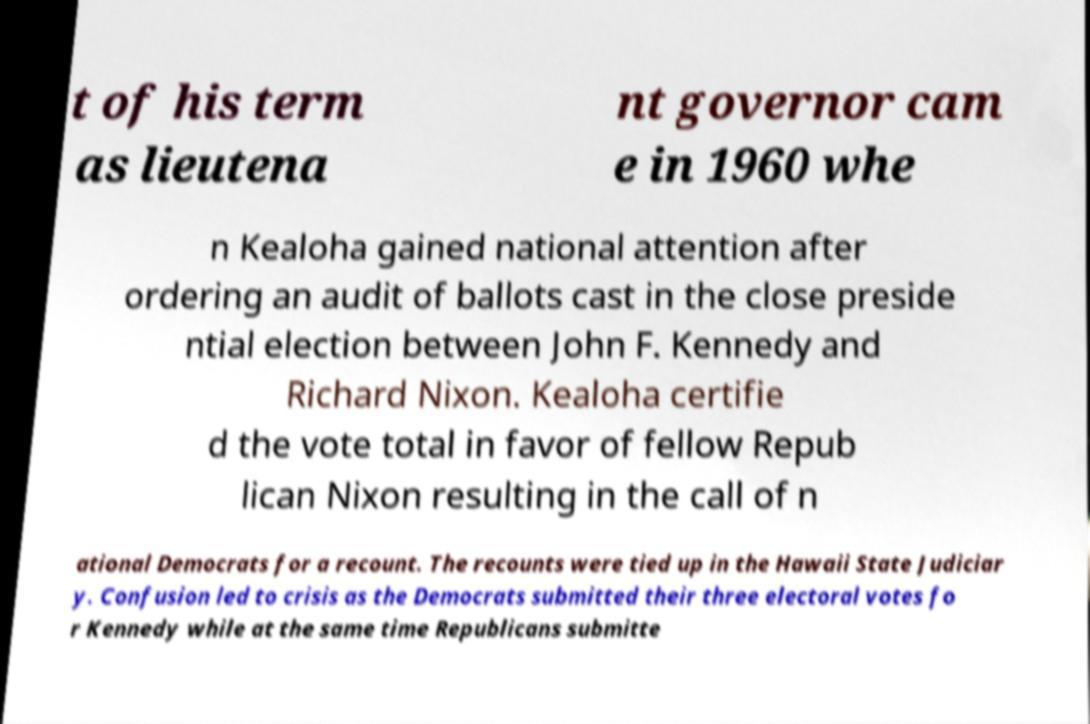I need the written content from this picture converted into text. Can you do that? t of his term as lieutena nt governor cam e in 1960 whe n Kealoha gained national attention after ordering an audit of ballots cast in the close preside ntial election between John F. Kennedy and Richard Nixon. Kealoha certifie d the vote total in favor of fellow Repub lican Nixon resulting in the call of n ational Democrats for a recount. The recounts were tied up in the Hawaii State Judiciar y. Confusion led to crisis as the Democrats submitted their three electoral votes fo r Kennedy while at the same time Republicans submitte 